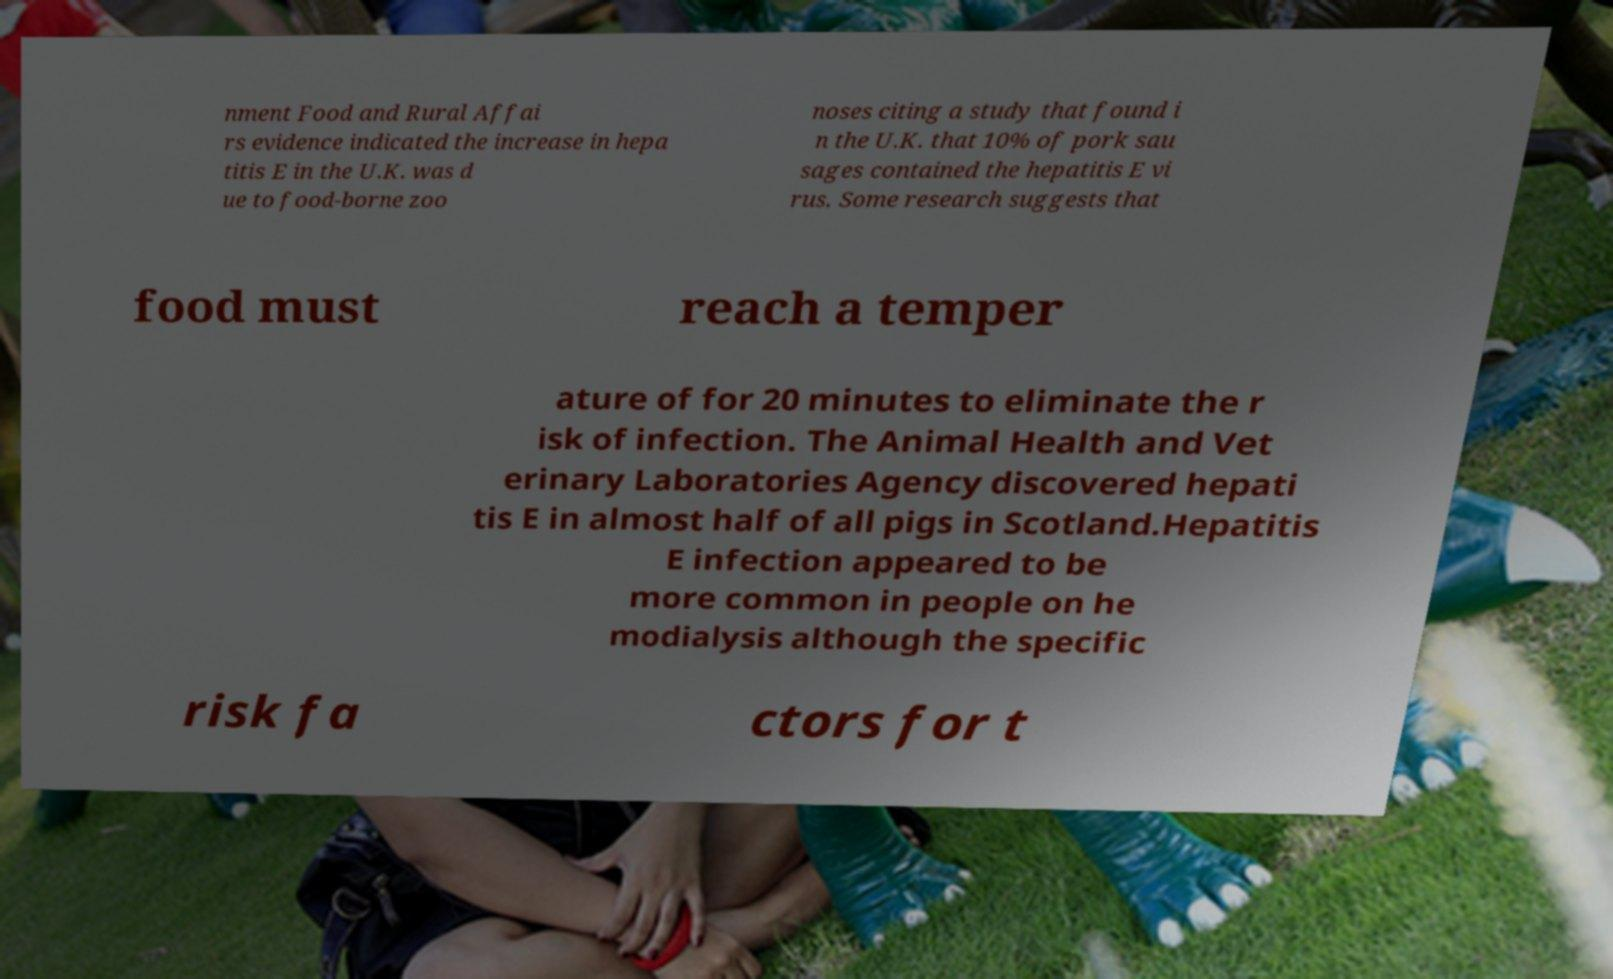There's text embedded in this image that I need extracted. Can you transcribe it verbatim? nment Food and Rural Affai rs evidence indicated the increase in hepa titis E in the U.K. was d ue to food-borne zoo noses citing a study that found i n the U.K. that 10% of pork sau sages contained the hepatitis E vi rus. Some research suggests that food must reach a temper ature of for 20 minutes to eliminate the r isk of infection. The Animal Health and Vet erinary Laboratories Agency discovered hepati tis E in almost half of all pigs in Scotland.Hepatitis E infection appeared to be more common in people on he modialysis although the specific risk fa ctors for t 